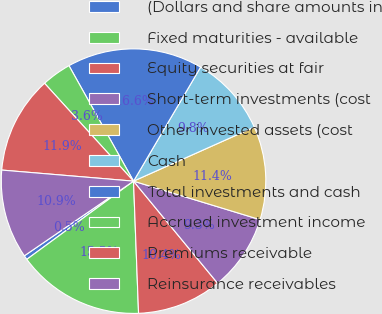<chart> <loc_0><loc_0><loc_500><loc_500><pie_chart><fcel>(Dollars and share amounts in<fcel>Fixed maturities - available<fcel>Equity securities at fair<fcel>Short-term investments (cost<fcel>Other invested assets (cost<fcel>Cash<fcel>Total investments and cash<fcel>Accrued investment income<fcel>Premiums receivable<fcel>Reinsurance receivables<nl><fcel>0.52%<fcel>15.54%<fcel>10.36%<fcel>9.33%<fcel>11.4%<fcel>9.84%<fcel>16.58%<fcel>3.63%<fcel>11.92%<fcel>10.88%<nl></chart> 